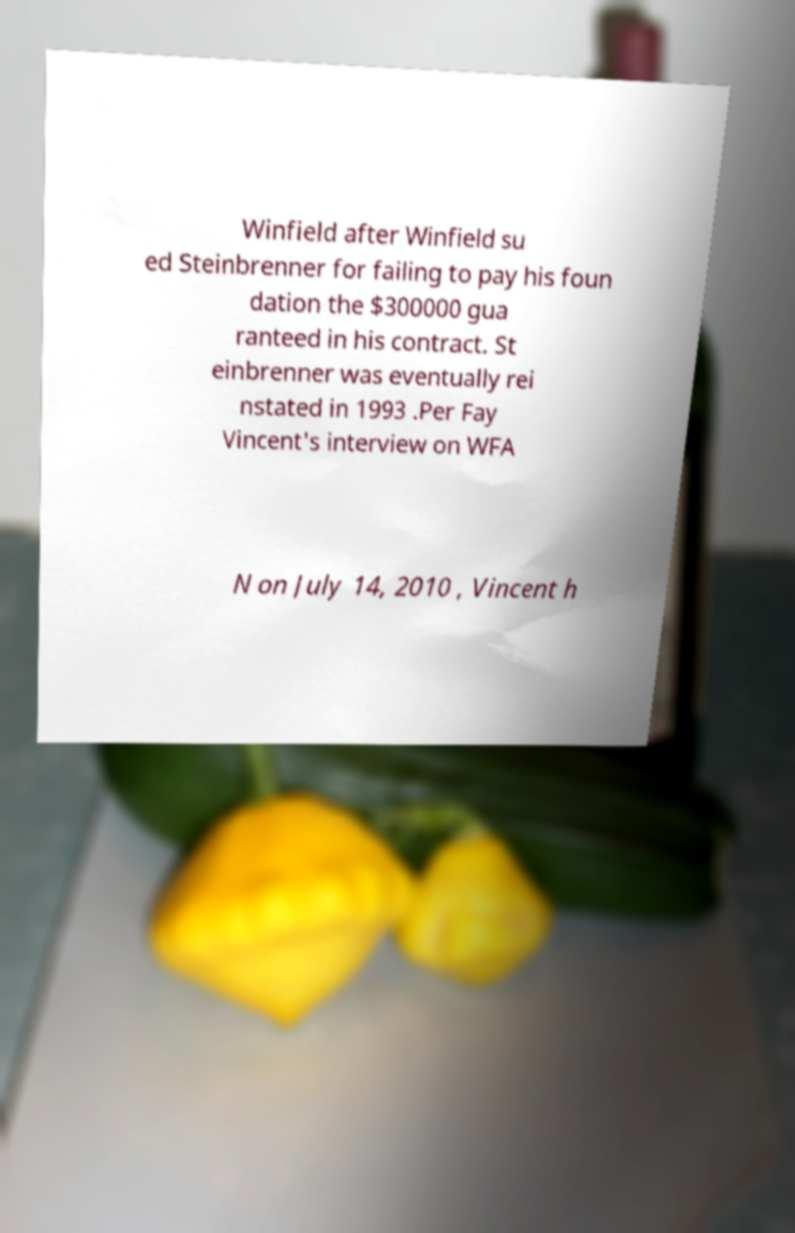Please read and relay the text visible in this image. What does it say? Winfield after Winfield su ed Steinbrenner for failing to pay his foun dation the $300000 gua ranteed in his contract. St einbrenner was eventually rei nstated in 1993 .Per Fay Vincent's interview on WFA N on July 14, 2010 , Vincent h 